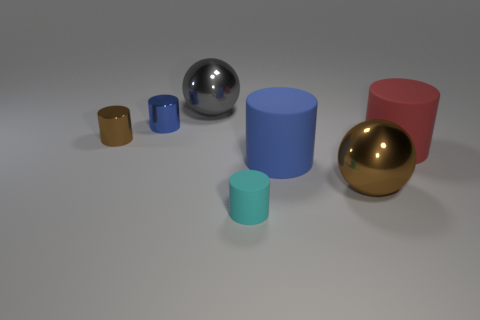Subtract all brown cylinders. How many cylinders are left? 4 Subtract all blue rubber cylinders. How many cylinders are left? 4 Subtract all cyan cylinders. Subtract all brown blocks. How many cylinders are left? 4 Add 1 big blue rubber balls. How many objects exist? 8 Subtract all spheres. How many objects are left? 5 Add 5 big objects. How many big objects exist? 9 Subtract 0 yellow spheres. How many objects are left? 7 Subtract all big yellow shiny cylinders. Subtract all tiny cyan things. How many objects are left? 6 Add 1 blue metallic cylinders. How many blue metallic cylinders are left? 2 